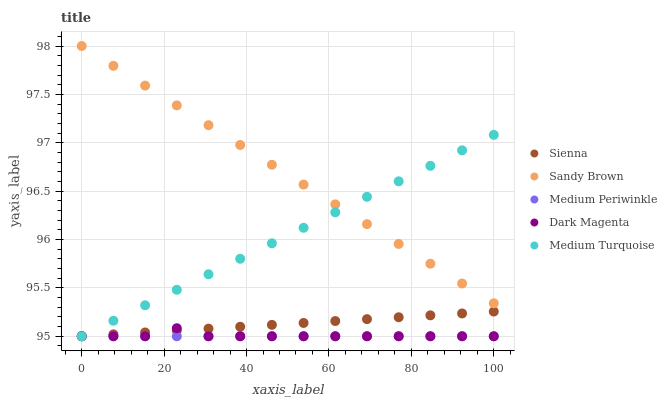Does Medium Periwinkle have the minimum area under the curve?
Answer yes or no. Yes. Does Sandy Brown have the maximum area under the curve?
Answer yes or no. Yes. Does Sandy Brown have the minimum area under the curve?
Answer yes or no. No. Does Medium Periwinkle have the maximum area under the curve?
Answer yes or no. No. Is Medium Periwinkle the smoothest?
Answer yes or no. Yes. Is Dark Magenta the roughest?
Answer yes or no. Yes. Is Sandy Brown the smoothest?
Answer yes or no. No. Is Sandy Brown the roughest?
Answer yes or no. No. Does Sienna have the lowest value?
Answer yes or no. Yes. Does Sandy Brown have the lowest value?
Answer yes or no. No. Does Sandy Brown have the highest value?
Answer yes or no. Yes. Does Medium Periwinkle have the highest value?
Answer yes or no. No. Is Dark Magenta less than Sandy Brown?
Answer yes or no. Yes. Is Sandy Brown greater than Medium Periwinkle?
Answer yes or no. Yes. Does Medium Turquoise intersect Sienna?
Answer yes or no. Yes. Is Medium Turquoise less than Sienna?
Answer yes or no. No. Is Medium Turquoise greater than Sienna?
Answer yes or no. No. Does Dark Magenta intersect Sandy Brown?
Answer yes or no. No. 